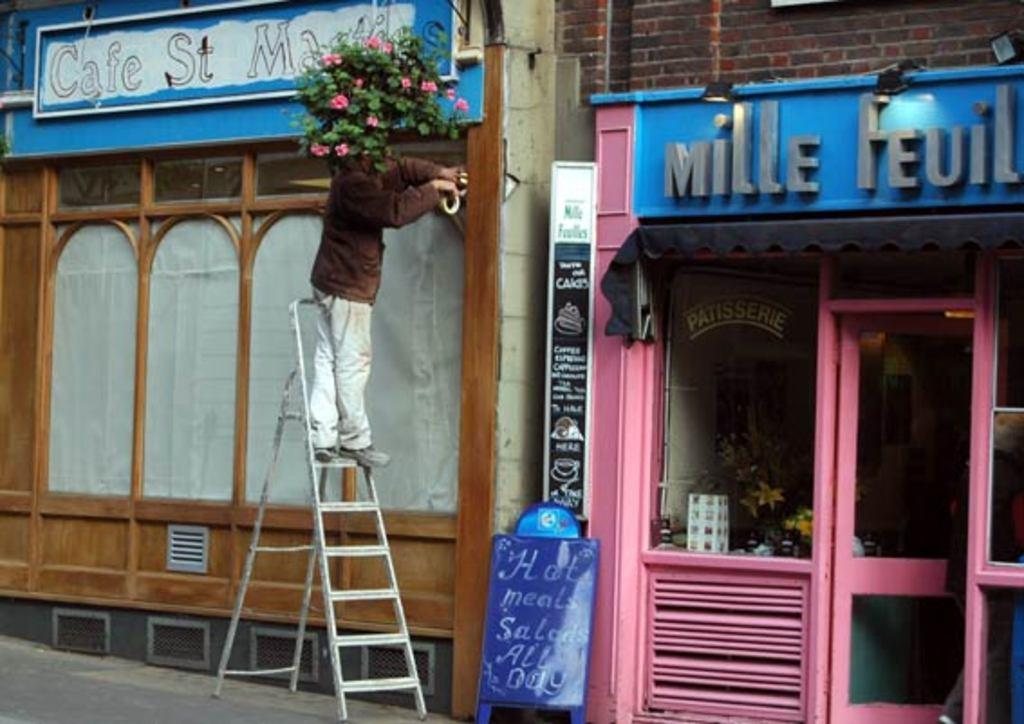<image>
Share a concise interpretation of the image provided. A store front with the word "Mille" above it 